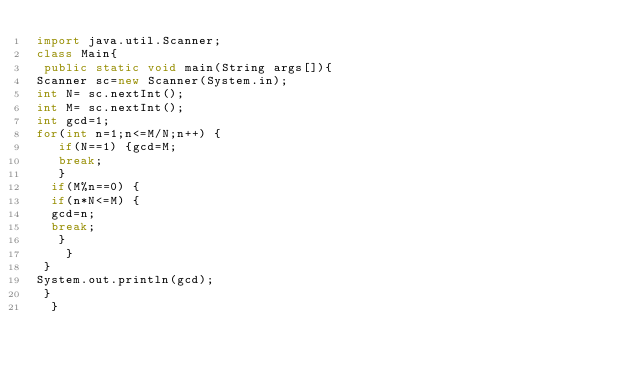Convert code to text. <code><loc_0><loc_0><loc_500><loc_500><_Java_>import java.util.Scanner;
class Main{
 public static void main(String args[]){
Scanner sc=new Scanner(System.in);
int N= sc.nextInt();
int M= sc.nextInt();
int gcd=1;
for(int n=1;n<=M/N;n++) {
   if(N==1) {gcd=M;
   break;
   }
	if(M%n==0) {
	if(n*N<=M) {
	gcd=n;
	break;
	 }
    }	
 }
System.out.println(gcd);
 }
  }
</code> 